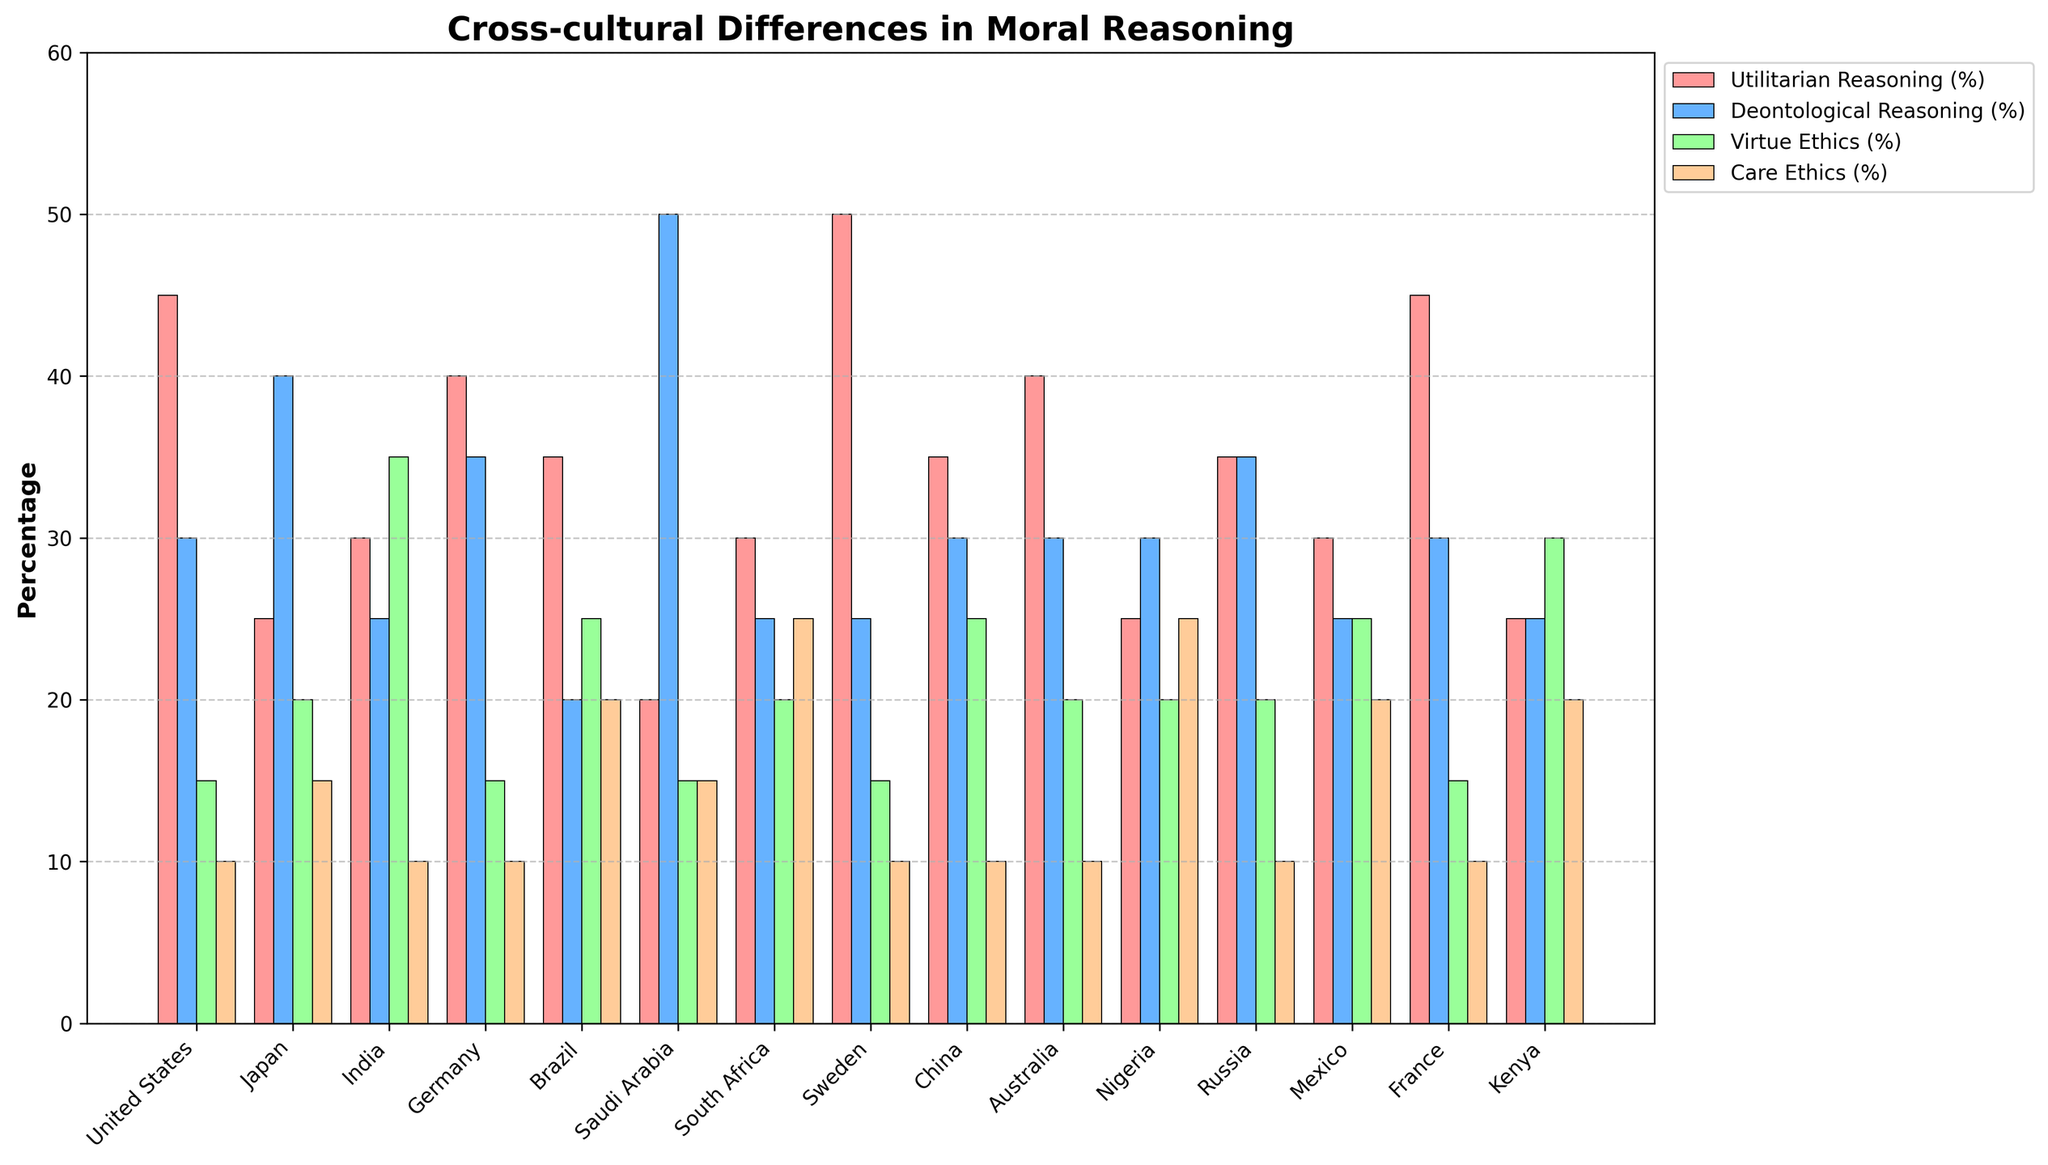Which country has the highest percentage of utilitarian reasoning? By looking at the bars representing Utilitarian Reasoning (in red) for all countries, it is evident which one is the tallest. The data shows that Sweden has the tallest red bar at 50%.
Answer: Sweden Which country has the lowest percentage of care ethics reasoning? By looking at the care ethics bars (in orange) for all countries, the shortest bars need to be identified. The data reveals that the United States, Germany, China, and Australia all have the shortest orange bars at 10%.
Answer: United States, Germany, China, Australia What's the total percentage of deontological reasoning for the countries Japan and Saudi Arabia? Find the values associated with deontological reasoning for Japan (40%) and Saudi Arabia (50%) and sum them up. 40 + 50 = 90.
Answer: 90 Which country's utilitarian reasoning percentage is closest to its deontological reasoning percentage? Examine both the Utilitarian and Deontological bars for each country and look for the smallest difference. The United States has 45% for Utilitarian and 30% for Deontological, with a difference of 15 percentage points, the smallest difference in the dataset.
Answer: United States If you combine Virtue Ethics and Care Ethics percentages, which country has the highest combined percentage? For each country, sum the Virtue Ethics (green) and Care Ethics (orange) bars, then find the maximum. Nigeria has a combined total of 20% (Virtue Ethics) + 25% (Care Ethics) = 45%.
Answer: Nigeria Which country has equal percentages of deontological reasoning and care ethics reasoning? Identify the country with identical heights of Deontological bars (blue) and Care Ethics bars (orange). Nigeria has equal percentages for both (30%).
Answer: Nigeria Does any country have all four types of reasoning percentages above 20%? Inspect the heights of all four types of bars for each country to see if they all surpass the 20% mark. No country has all four bar heights above 20%.
Answer: No For Germany, what's the difference between utilitarian reasoning and virtue ethics? Subtract the Virtue Ethics percentage from the Utilitarian Reasoning percentage for Germany. Utilitarian Reasoning (40%) - Virtue Ethics (15%) = 25%.
Answer: 25 Which country has the broadest range between its highest and lowest reasoning percentages? Calculate the range by subtracting the lowest percentage from the highest for each country and compare. Saudi Arabia has the broadest range, from 50% (Deontological Reasoning) to 15% (Virtue Ethics), giving a range of 50 - 15 = 35.
Answer: Saudi Arabia How many countries have at least one reasoning type percentage above 40%? Count the countries with at least one bar height exceeding 40%. The countries are Japan, Sweden, Saudi Arabia, and Russia.
Answer: 4 